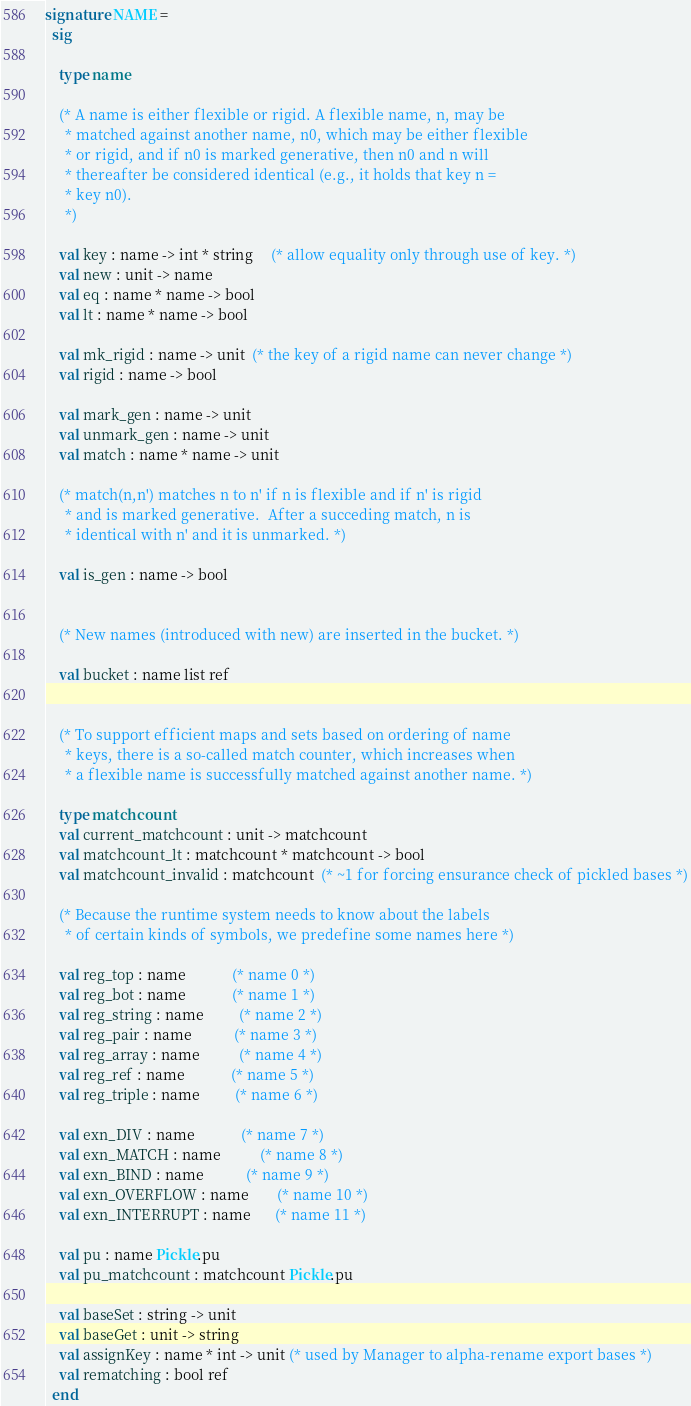<code> <loc_0><loc_0><loc_500><loc_500><_SML_>
signature NAME =
  sig

    type name

    (* A name is either flexible or rigid. A flexible name, n, may be
     * matched against another name, n0, which may be either flexible
     * or rigid, and if n0 is marked generative, then n0 and n will
     * thereafter be considered identical (e.g., it holds that key n =
     * key n0). 
     *)

    val key : name -> int * string     (* allow equality only through use of key. *)
    val new : unit -> name
    val eq : name * name -> bool
    val lt : name * name -> bool

    val mk_rigid : name -> unit  (* the key of a rigid name can never change *)
    val rigid : name -> bool

    val mark_gen : name -> unit
    val unmark_gen : name -> unit
    val match : name * name -> unit

    (* match(n,n') matches n to n' if n is flexible and if n' is rigid
     * and is marked generative.  After a succeding match, n is
     * identical with n' and it is unmarked. *)

    val is_gen : name -> bool


    (* New names (introduced with new) are inserted in the bucket. *)

    val bucket : name list ref

      
    (* To support efficient maps and sets based on ordering of name
     * keys, there is a so-called match counter, which increases when
     * a flexible name is successfully matched against another name. *)

    type matchcount                                     
    val current_matchcount : unit -> matchcount          
    val matchcount_lt : matchcount * matchcount -> bool
    val matchcount_invalid : matchcount  (* ~1 for forcing ensurance check of pickled bases *)

    (* Because the runtime system needs to know about the labels
     * of certain kinds of symbols, we predefine some names here *)

    val reg_top : name             (* name 0 *)
    val reg_bot : name             (* name 1 *)
    val reg_string : name          (* name 2 *)
    val reg_pair : name            (* name 3 *)
    val reg_array : name           (* name 4 *)
    val reg_ref : name             (* name 5 *)
    val reg_triple : name          (* name 6 *)

    val exn_DIV : name             (* name 7 *)
    val exn_MATCH : name           (* name 8 *)
    val exn_BIND : name            (* name 9 *)
    val exn_OVERFLOW : name        (* name 10 *)
    val exn_INTERRUPT : name       (* name 11 *)

    val pu : name Pickle.pu
    val pu_matchcount : matchcount Pickle.pu

    val baseSet : string -> unit
    val baseGet : unit -> string
    val assignKey : name * int -> unit (* used by Manager to alpha-rename export bases *)
    val rematching : bool ref
  end
</code> 